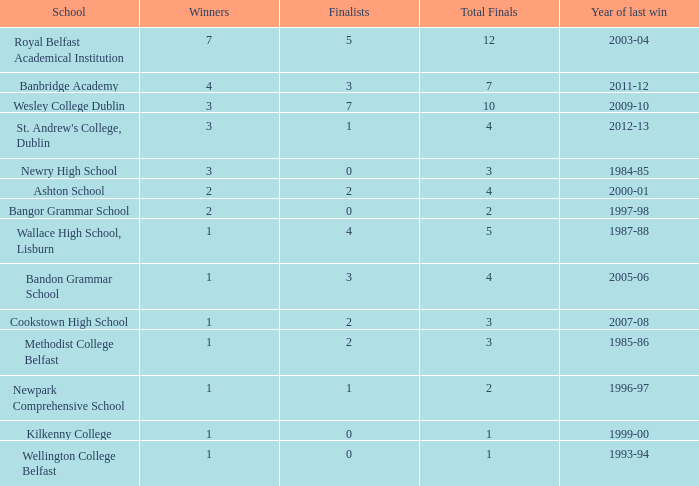How many times was banbridge academy the winner? 1.0. 